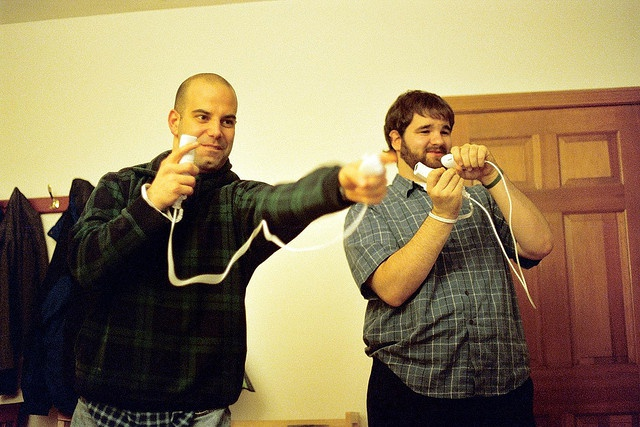Describe the objects in this image and their specific colors. I can see people in tan, black, gold, darkgreen, and orange tones, people in tan, black, gray, and orange tones, remote in tan, beige, and khaki tones, remote in tan, beige, and khaki tones, and remote in tan, ivory, and khaki tones in this image. 